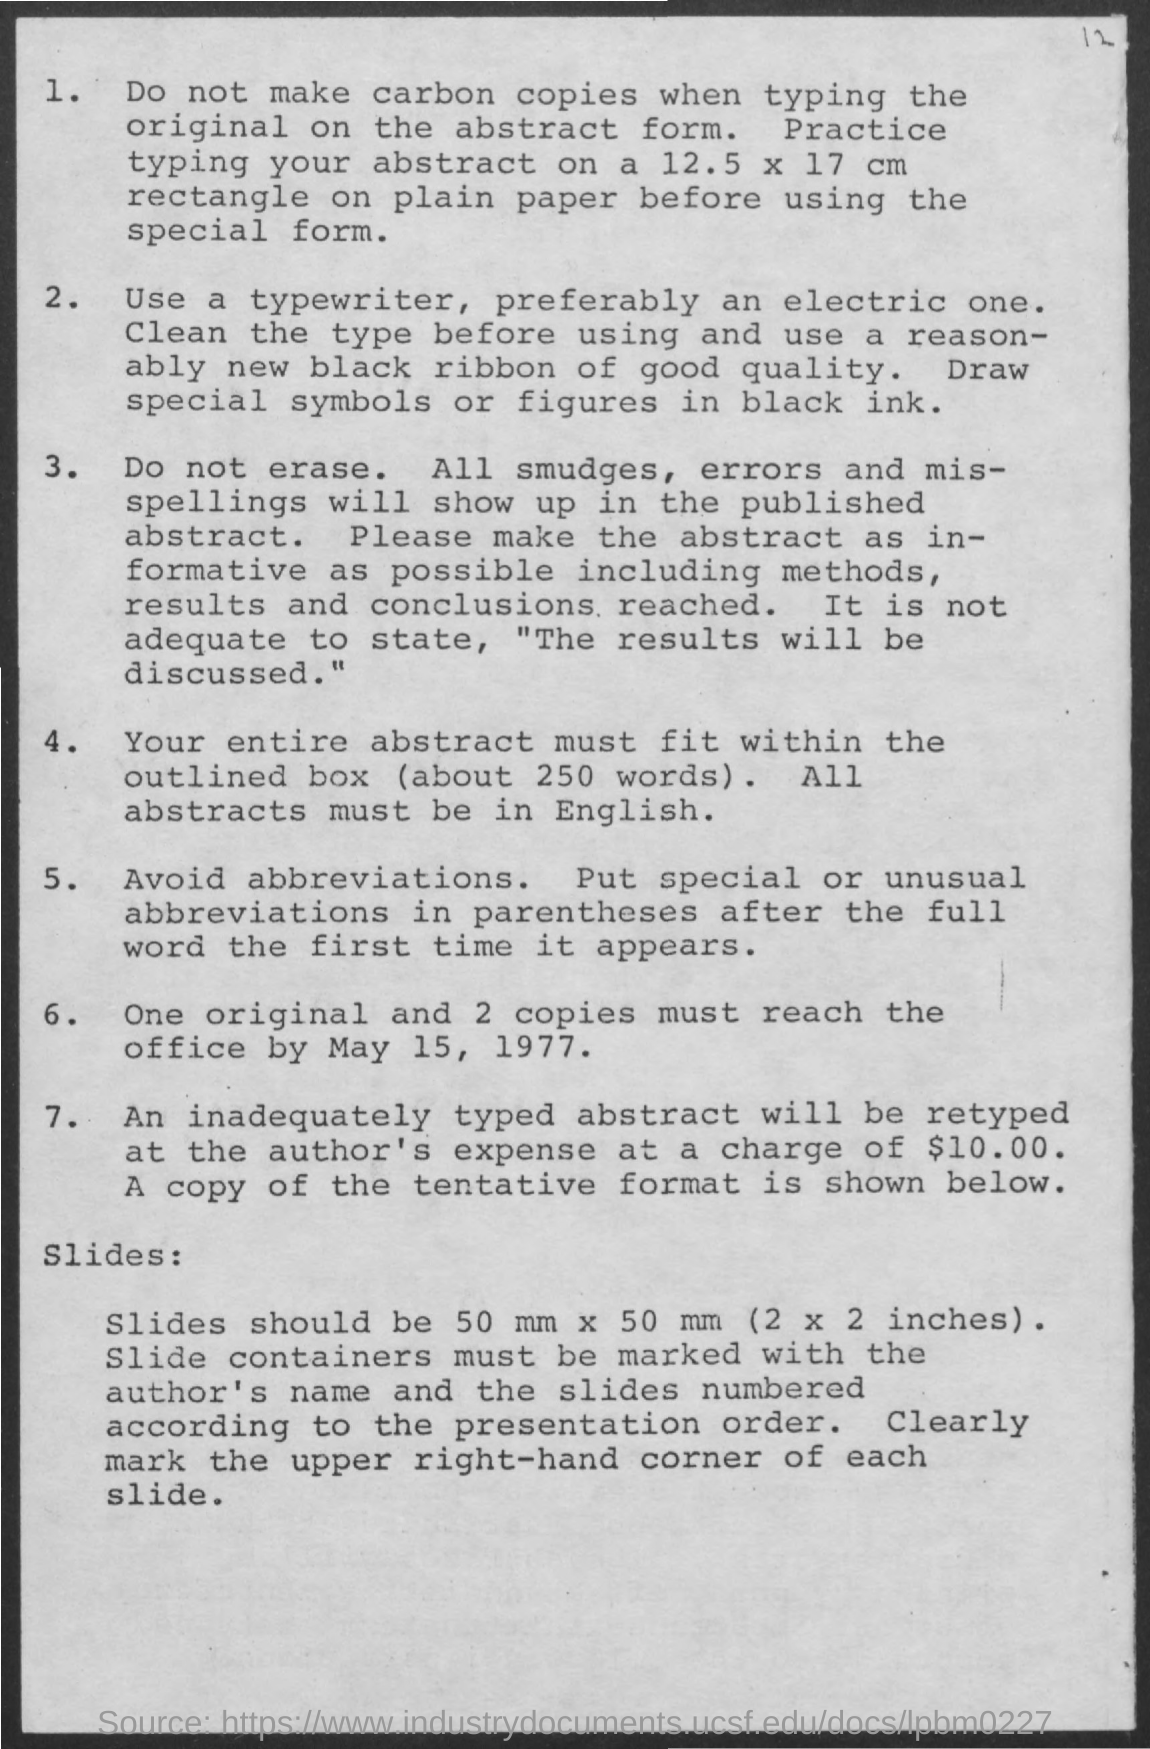Give some essential details in this illustration. It is appropriate for the abstract to be written in English. The cost of retyping is $10.00. The preferred paper size for typing an abstract is 12.5 inches by 17 inches. It is preferred to use an electric typewriter. 